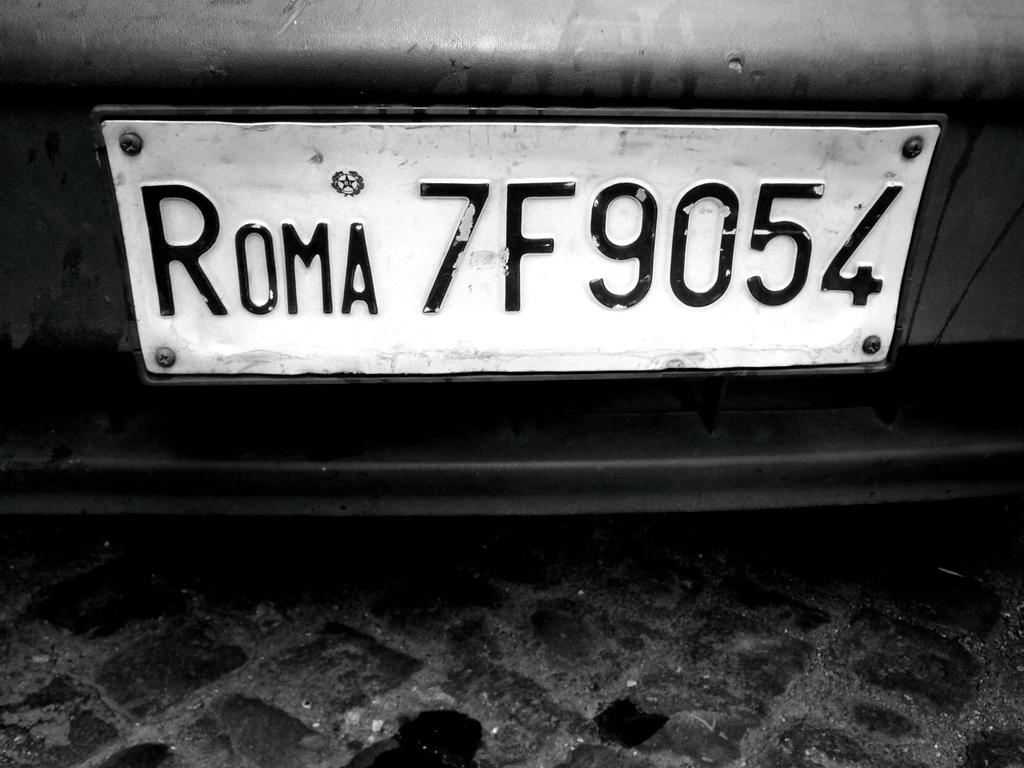<image>
Give a short and clear explanation of the subsequent image. A white license plate with black letters of Roma 7F9054. 